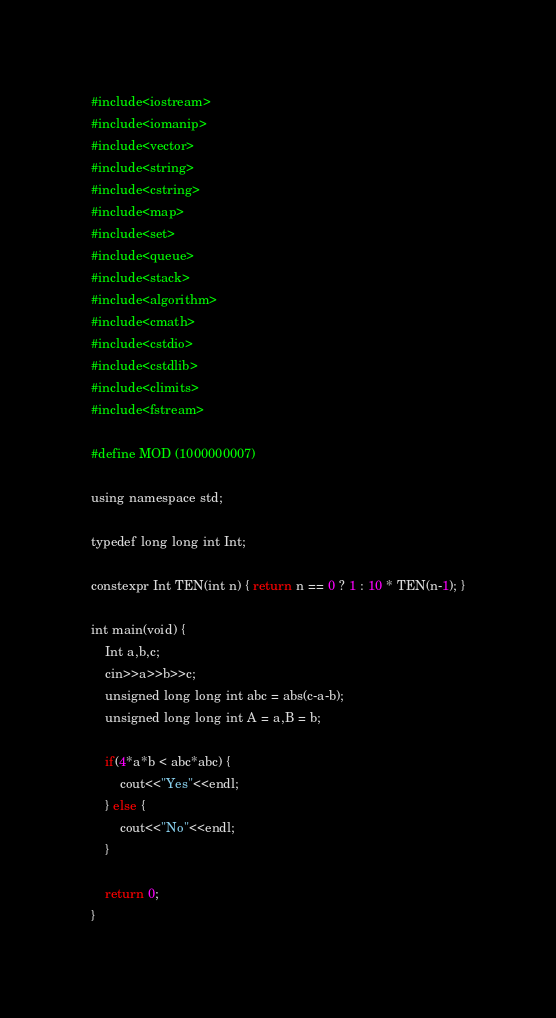<code> <loc_0><loc_0><loc_500><loc_500><_Python_>#include<iostream>
#include<iomanip>
#include<vector>
#include<string>
#include<cstring>
#include<map>
#include<set>
#include<queue>
#include<stack>
#include<algorithm>
#include<cmath>
#include<cstdio>
#include<cstdlib>
#include<climits>
#include<fstream>

#define MOD (1000000007)

using namespace std;

typedef long long int Int;

constexpr Int TEN(int n) { return n == 0 ? 1 : 10 * TEN(n-1); }

int main(void) {
    Int a,b,c;
    cin>>a>>b>>c;
    unsigned long long int abc = abs(c-a-b);
    unsigned long long int A = a,B = b;

    if(4*a*b < abc*abc) {
        cout<<"Yes"<<endl;
    } else {
        cout<<"No"<<endl;
    }

    return 0;
}


</code> 